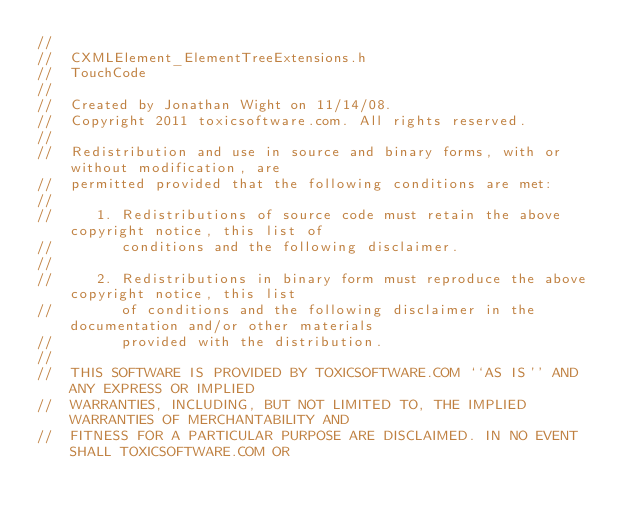<code> <loc_0><loc_0><loc_500><loc_500><_C_>//
//  CXMLElement_ElementTreeExtensions.h
//  TouchCode
//
//  Created by Jonathan Wight on 11/14/08.
//  Copyright 2011 toxicsoftware.com. All rights reserved.
//
//  Redistribution and use in source and binary forms, with or without modification, are
//  permitted provided that the following conditions are met:
//
//     1. Redistributions of source code must retain the above copyright notice, this list of
//        conditions and the following disclaimer.
//
//     2. Redistributions in binary form must reproduce the above copyright notice, this list
//        of conditions and the following disclaimer in the documentation and/or other materials
//        provided with the distribution.
//
//  THIS SOFTWARE IS PROVIDED BY TOXICSOFTWARE.COM ``AS IS'' AND ANY EXPRESS OR IMPLIED
//  WARRANTIES, INCLUDING, BUT NOT LIMITED TO, THE IMPLIED WARRANTIES OF MERCHANTABILITY AND
//  FITNESS FOR A PARTICULAR PURPOSE ARE DISCLAIMED. IN NO EVENT SHALL TOXICSOFTWARE.COM OR</code> 